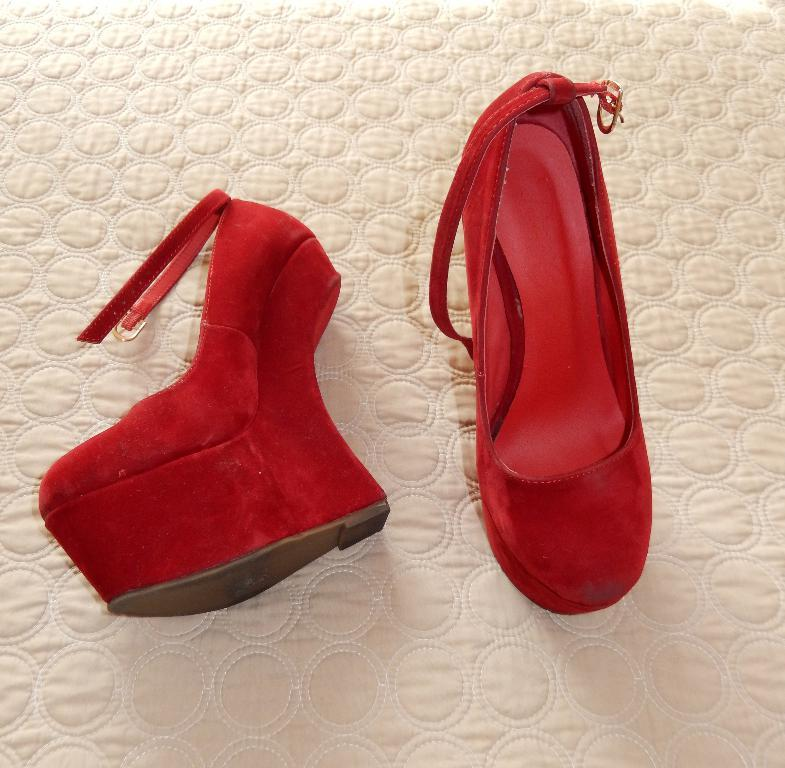What type of footwear is visible in the image? There are red color heels in the image. On what surface are the heels placed? The heels are placed on an object that seems to be a mat. What type of advice can be seen written on the heels in the image? There is no advice written on the heels in the image; they are simply red color heels placed on a mat. 